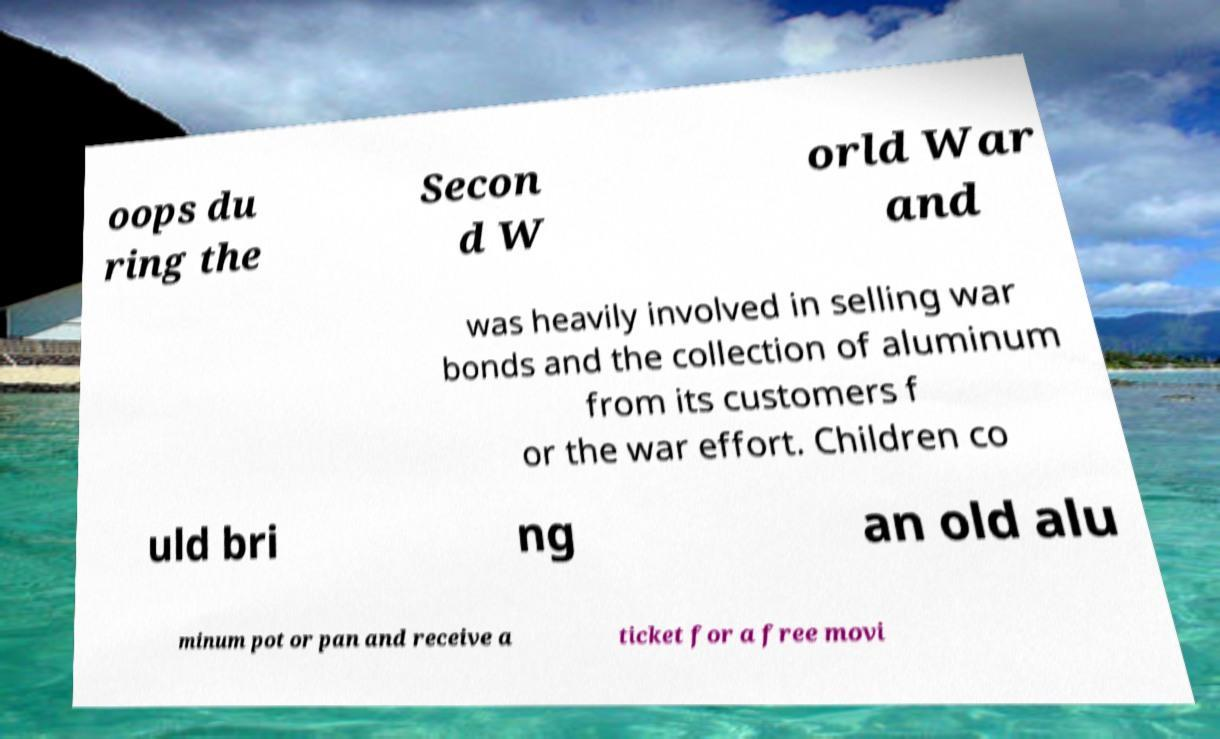What messages or text are displayed in this image? I need them in a readable, typed format. oops du ring the Secon d W orld War and was heavily involved in selling war bonds and the collection of aluminum from its customers f or the war effort. Children co uld bri ng an old alu minum pot or pan and receive a ticket for a free movi 